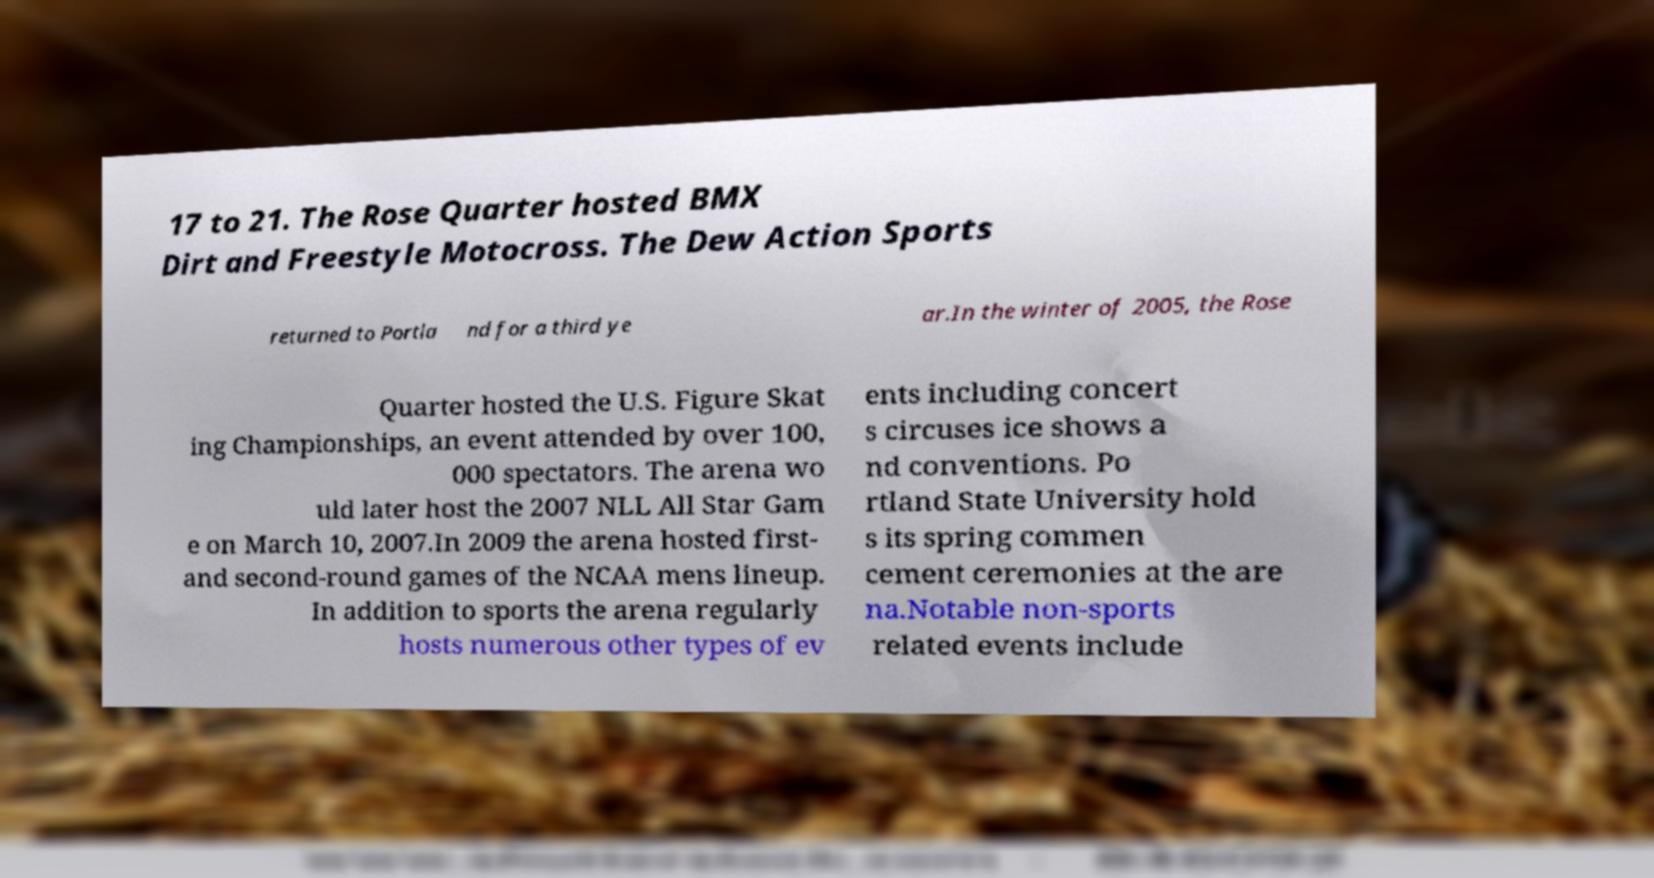Please identify and transcribe the text found in this image. 17 to 21. The Rose Quarter hosted BMX Dirt and Freestyle Motocross. The Dew Action Sports returned to Portla nd for a third ye ar.In the winter of 2005, the Rose Quarter hosted the U.S. Figure Skat ing Championships, an event attended by over 100, 000 spectators. The arena wo uld later host the 2007 NLL All Star Gam e on March 10, 2007.In 2009 the arena hosted first- and second-round games of the NCAA mens lineup. In addition to sports the arena regularly hosts numerous other types of ev ents including concert s circuses ice shows a nd conventions. Po rtland State University hold s its spring commen cement ceremonies at the are na.Notable non-sports related events include 